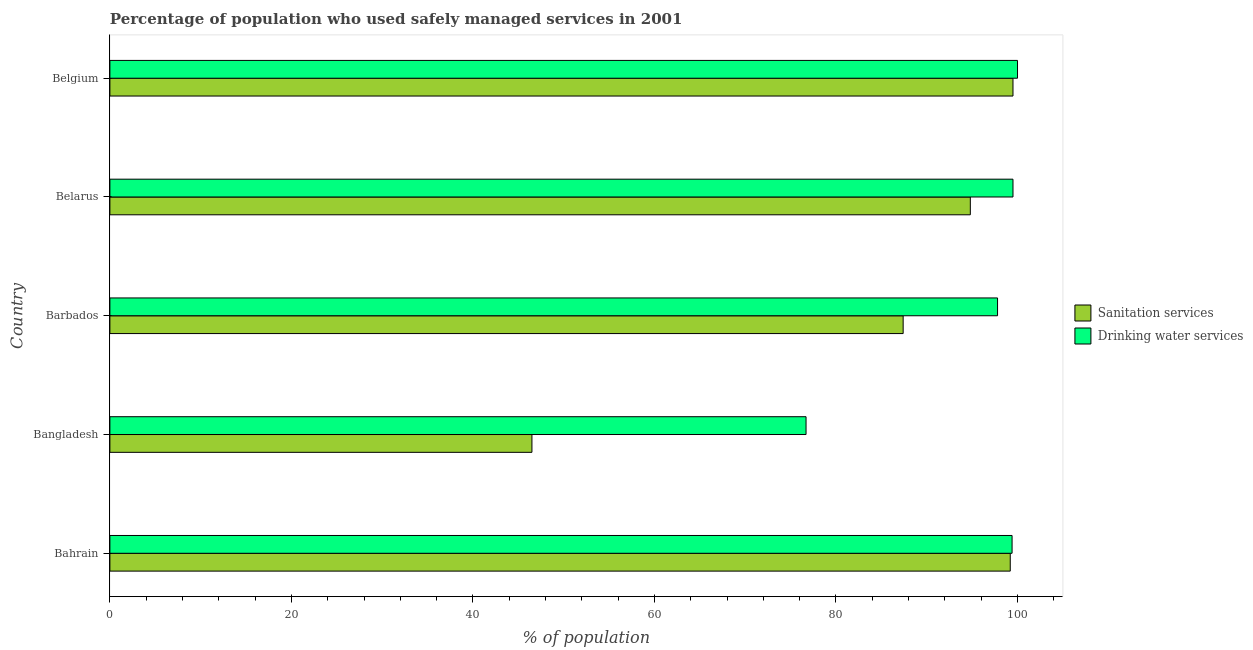How many different coloured bars are there?
Offer a very short reply. 2. How many groups of bars are there?
Make the answer very short. 5. Are the number of bars per tick equal to the number of legend labels?
Offer a very short reply. Yes. How many bars are there on the 3rd tick from the top?
Your response must be concise. 2. What is the percentage of population who used drinking water services in Belarus?
Ensure brevity in your answer.  99.5. Across all countries, what is the maximum percentage of population who used sanitation services?
Give a very brief answer. 99.5. Across all countries, what is the minimum percentage of population who used sanitation services?
Offer a terse response. 46.5. In which country was the percentage of population who used sanitation services maximum?
Offer a very short reply. Belgium. In which country was the percentage of population who used drinking water services minimum?
Make the answer very short. Bangladesh. What is the total percentage of population who used drinking water services in the graph?
Your answer should be very brief. 473.4. What is the difference between the percentage of population who used sanitation services in Bahrain and that in Bangladesh?
Keep it short and to the point. 52.7. What is the difference between the percentage of population who used sanitation services in Bahrain and the percentage of population who used drinking water services in Belgium?
Offer a terse response. -0.8. What is the average percentage of population who used sanitation services per country?
Your response must be concise. 85.48. What is the ratio of the percentage of population who used sanitation services in Bahrain to that in Belarus?
Keep it short and to the point. 1.05. Is the percentage of population who used sanitation services in Bahrain less than that in Bangladesh?
Offer a terse response. No. Is the sum of the percentage of population who used drinking water services in Bangladesh and Belgium greater than the maximum percentage of population who used sanitation services across all countries?
Keep it short and to the point. Yes. What does the 2nd bar from the top in Barbados represents?
Offer a very short reply. Sanitation services. What does the 2nd bar from the bottom in Belgium represents?
Your response must be concise. Drinking water services. How many bars are there?
Provide a short and direct response. 10. Are all the bars in the graph horizontal?
Your answer should be compact. Yes. How many countries are there in the graph?
Provide a short and direct response. 5. What is the difference between two consecutive major ticks on the X-axis?
Keep it short and to the point. 20. Are the values on the major ticks of X-axis written in scientific E-notation?
Offer a very short reply. No. Does the graph contain any zero values?
Your answer should be compact. No. Does the graph contain grids?
Ensure brevity in your answer.  No. How many legend labels are there?
Your answer should be compact. 2. How are the legend labels stacked?
Your response must be concise. Vertical. What is the title of the graph?
Provide a short and direct response. Percentage of population who used safely managed services in 2001. Does "Under-5(male)" appear as one of the legend labels in the graph?
Make the answer very short. No. What is the label or title of the X-axis?
Your response must be concise. % of population. What is the label or title of the Y-axis?
Keep it short and to the point. Country. What is the % of population of Sanitation services in Bahrain?
Make the answer very short. 99.2. What is the % of population in Drinking water services in Bahrain?
Offer a very short reply. 99.4. What is the % of population of Sanitation services in Bangladesh?
Keep it short and to the point. 46.5. What is the % of population in Drinking water services in Bangladesh?
Your answer should be compact. 76.7. What is the % of population of Sanitation services in Barbados?
Offer a terse response. 87.4. What is the % of population of Drinking water services in Barbados?
Keep it short and to the point. 97.8. What is the % of population of Sanitation services in Belarus?
Make the answer very short. 94.8. What is the % of population in Drinking water services in Belarus?
Your answer should be very brief. 99.5. What is the % of population in Sanitation services in Belgium?
Make the answer very short. 99.5. Across all countries, what is the maximum % of population in Sanitation services?
Offer a very short reply. 99.5. Across all countries, what is the maximum % of population in Drinking water services?
Ensure brevity in your answer.  100. Across all countries, what is the minimum % of population in Sanitation services?
Make the answer very short. 46.5. Across all countries, what is the minimum % of population of Drinking water services?
Provide a short and direct response. 76.7. What is the total % of population in Sanitation services in the graph?
Provide a succinct answer. 427.4. What is the total % of population in Drinking water services in the graph?
Provide a succinct answer. 473.4. What is the difference between the % of population in Sanitation services in Bahrain and that in Bangladesh?
Keep it short and to the point. 52.7. What is the difference between the % of population of Drinking water services in Bahrain and that in Bangladesh?
Provide a short and direct response. 22.7. What is the difference between the % of population of Drinking water services in Bahrain and that in Barbados?
Your answer should be very brief. 1.6. What is the difference between the % of population of Sanitation services in Bahrain and that in Belarus?
Provide a short and direct response. 4.4. What is the difference between the % of population in Drinking water services in Bahrain and that in Belarus?
Your answer should be very brief. -0.1. What is the difference between the % of population in Sanitation services in Bangladesh and that in Barbados?
Offer a terse response. -40.9. What is the difference between the % of population of Drinking water services in Bangladesh and that in Barbados?
Your response must be concise. -21.1. What is the difference between the % of population in Sanitation services in Bangladesh and that in Belarus?
Your answer should be very brief. -48.3. What is the difference between the % of population of Drinking water services in Bangladesh and that in Belarus?
Your response must be concise. -22.8. What is the difference between the % of population in Sanitation services in Bangladesh and that in Belgium?
Give a very brief answer. -53. What is the difference between the % of population in Drinking water services in Bangladesh and that in Belgium?
Your answer should be compact. -23.3. What is the difference between the % of population of Sanitation services in Barbados and that in Belarus?
Offer a terse response. -7.4. What is the difference between the % of population in Sanitation services in Barbados and that in Belgium?
Offer a terse response. -12.1. What is the difference between the % of population of Drinking water services in Barbados and that in Belgium?
Your response must be concise. -2.2. What is the difference between the % of population of Drinking water services in Belarus and that in Belgium?
Give a very brief answer. -0.5. What is the difference between the % of population of Sanitation services in Bahrain and the % of population of Drinking water services in Bangladesh?
Provide a short and direct response. 22.5. What is the difference between the % of population in Sanitation services in Bahrain and the % of population in Drinking water services in Barbados?
Keep it short and to the point. 1.4. What is the difference between the % of population of Sanitation services in Bahrain and the % of population of Drinking water services in Belarus?
Your response must be concise. -0.3. What is the difference between the % of population in Sanitation services in Bangladesh and the % of population in Drinking water services in Barbados?
Provide a succinct answer. -51.3. What is the difference between the % of population in Sanitation services in Bangladesh and the % of population in Drinking water services in Belarus?
Provide a succinct answer. -53. What is the difference between the % of population in Sanitation services in Bangladesh and the % of population in Drinking water services in Belgium?
Your response must be concise. -53.5. What is the difference between the % of population of Sanitation services in Barbados and the % of population of Drinking water services in Belarus?
Keep it short and to the point. -12.1. What is the average % of population in Sanitation services per country?
Give a very brief answer. 85.48. What is the average % of population of Drinking water services per country?
Provide a succinct answer. 94.68. What is the difference between the % of population in Sanitation services and % of population in Drinking water services in Bangladesh?
Offer a very short reply. -30.2. What is the difference between the % of population of Sanitation services and % of population of Drinking water services in Barbados?
Give a very brief answer. -10.4. What is the ratio of the % of population in Sanitation services in Bahrain to that in Bangladesh?
Your answer should be very brief. 2.13. What is the ratio of the % of population in Drinking water services in Bahrain to that in Bangladesh?
Keep it short and to the point. 1.3. What is the ratio of the % of population of Sanitation services in Bahrain to that in Barbados?
Keep it short and to the point. 1.14. What is the ratio of the % of population of Drinking water services in Bahrain to that in Barbados?
Offer a very short reply. 1.02. What is the ratio of the % of population of Sanitation services in Bahrain to that in Belarus?
Your response must be concise. 1.05. What is the ratio of the % of population in Sanitation services in Bahrain to that in Belgium?
Give a very brief answer. 1. What is the ratio of the % of population in Sanitation services in Bangladesh to that in Barbados?
Give a very brief answer. 0.53. What is the ratio of the % of population of Drinking water services in Bangladesh to that in Barbados?
Your answer should be very brief. 0.78. What is the ratio of the % of population of Sanitation services in Bangladesh to that in Belarus?
Offer a terse response. 0.49. What is the ratio of the % of population in Drinking water services in Bangladesh to that in Belarus?
Give a very brief answer. 0.77. What is the ratio of the % of population in Sanitation services in Bangladesh to that in Belgium?
Your response must be concise. 0.47. What is the ratio of the % of population of Drinking water services in Bangladesh to that in Belgium?
Keep it short and to the point. 0.77. What is the ratio of the % of population of Sanitation services in Barbados to that in Belarus?
Your answer should be compact. 0.92. What is the ratio of the % of population in Drinking water services in Barbados to that in Belarus?
Offer a terse response. 0.98. What is the ratio of the % of population in Sanitation services in Barbados to that in Belgium?
Your answer should be compact. 0.88. What is the ratio of the % of population of Drinking water services in Barbados to that in Belgium?
Offer a terse response. 0.98. What is the ratio of the % of population in Sanitation services in Belarus to that in Belgium?
Provide a short and direct response. 0.95. What is the ratio of the % of population in Drinking water services in Belarus to that in Belgium?
Offer a very short reply. 0.99. What is the difference between the highest and the second highest % of population of Drinking water services?
Give a very brief answer. 0.5. What is the difference between the highest and the lowest % of population in Drinking water services?
Make the answer very short. 23.3. 